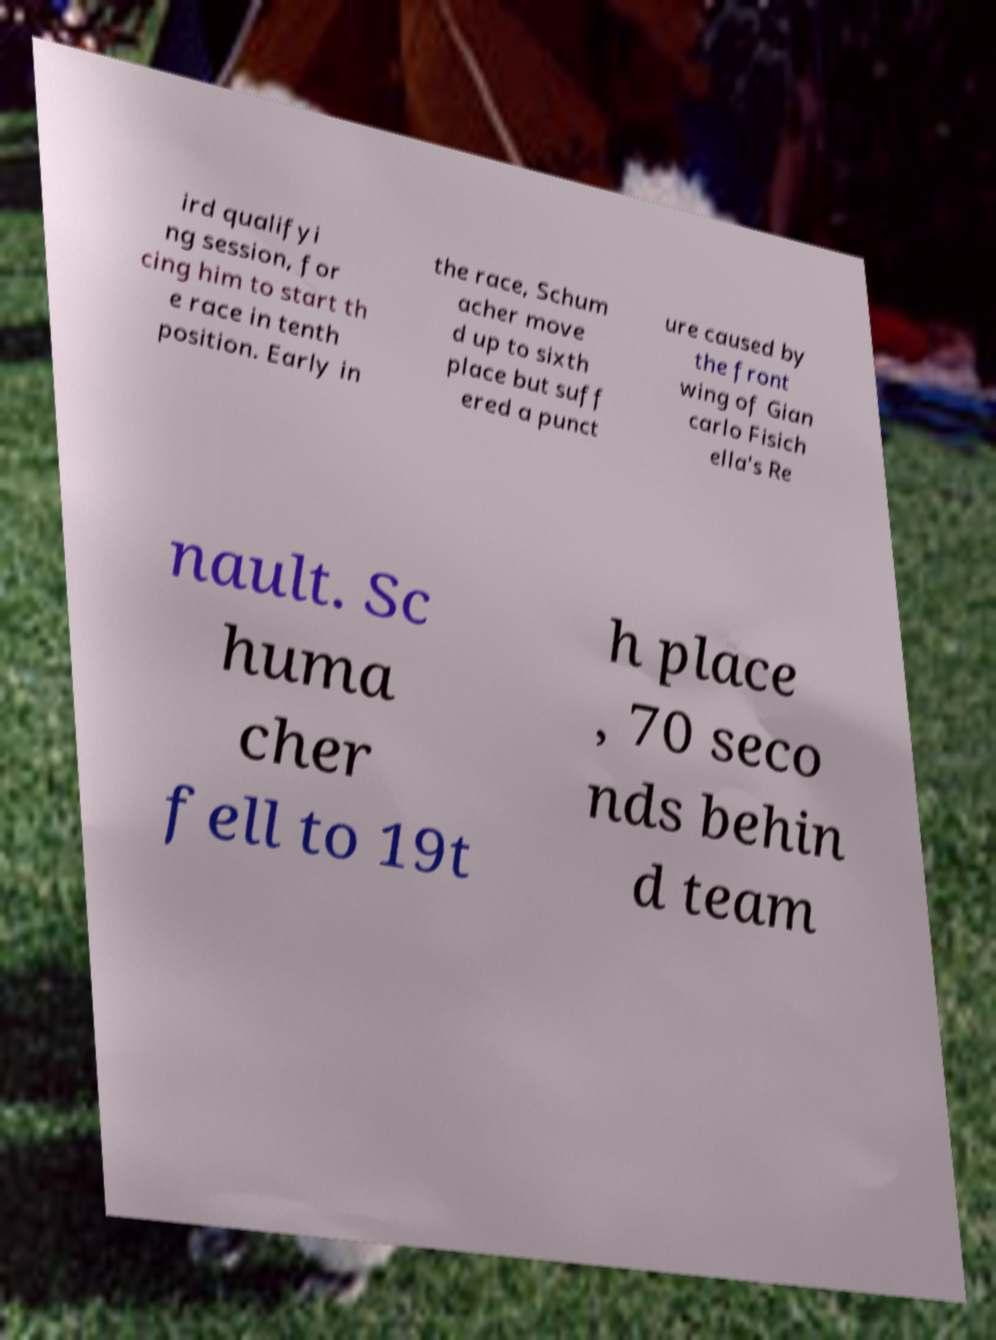Please read and relay the text visible in this image. What does it say? ird qualifyi ng session, for cing him to start th e race in tenth position. Early in the race, Schum acher move d up to sixth place but suff ered a punct ure caused by the front wing of Gian carlo Fisich ella's Re nault. Sc huma cher fell to 19t h place , 70 seco nds behin d team 